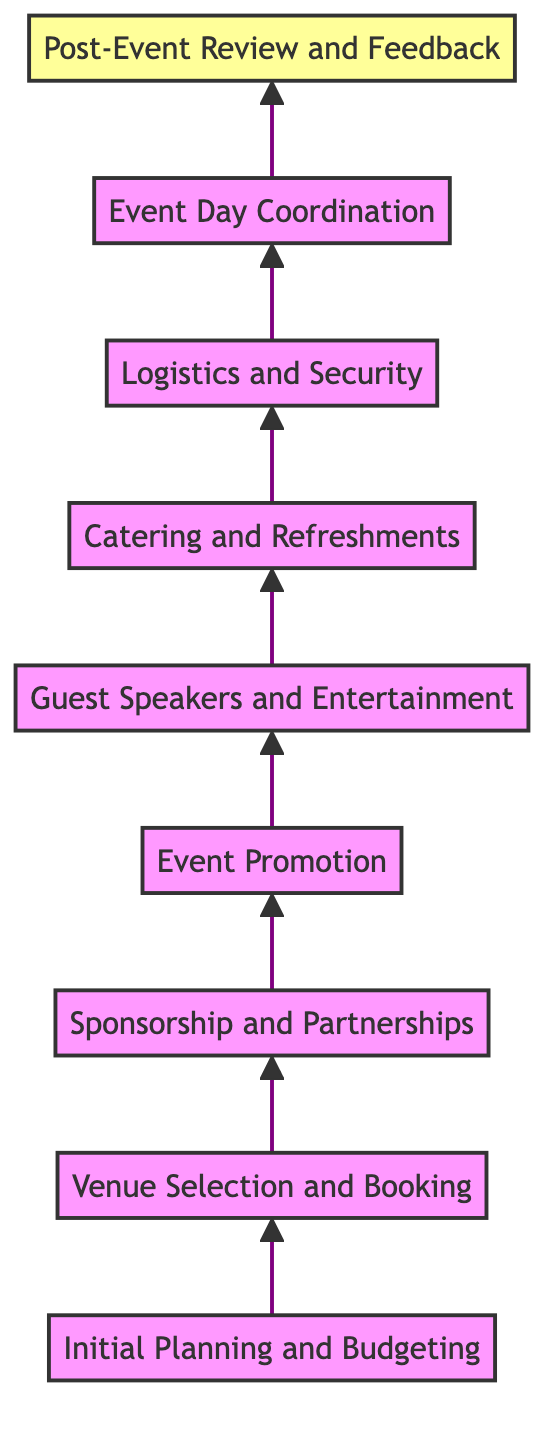What is the final step in the organization process? The flowchart indicates that the final step, after all other processes are completed, is "Post-Event Review and Feedback." This is the last node in the upward flow from the initial planning to the conclusion of the event organization.
Answer: Post-Event Review and Feedback How many total steps are in the diagram? The diagram consists of 9 distinct elements, starting from "Initial Planning and Budgeting" to "Post-Event Review and Feedback." Each step corresponds to an essential part of the event organization process.
Answer: 9 What is the relationship between "Event Promotion" and "Guest Speakers and Entertainment"? "Event Promotion" is a step that comes directly before "Guest Speakers and Entertainment" in the flowchart. This implies that promoting the event occurs prior to inviting speakers and entertainers, indicating a logical sequence in the planning process.
Answer: Event Promotion comes before Guest Speakers and Entertainment Which node involves coordinating safety measures? The node titled "Logistics and Security" is responsible for coordinating all safety measures related to the event. It comes after the food arrangements and before the actual day of the event, highlighting its importance in ensuring a secure environment.
Answer: Logistics and Security What step directly follows "Sponsorship and Partnerships"? The next step after "Sponsorship and Partnerships" is "Event Promotion." This indicates that securing sponsorship precedes the promotional activities which are crucial for raising awareness of the event.
Answer: Event Promotion Which step is characterized by inviting notable veterans? The step characterized by inviting notable veterans is "Guest Speakers and Entertainment." This is explicitly highlighted in the description of that particular node.
Answer: Guest Speakers and Entertainment What is the second step in the flowchart? The second step in the flowchart is "Venue Selection and Booking." This step follows the initial planning and is crucial for establishing the event's location.
Answer: Venue Selection and Booking How do you ensure event execution goes smoothly? "Event Day Coordination" specifically addresses ensuring the smooth execution of the event schedule and dealing with any issues that arise during the event. This reflects its importance on the day of the meetup.
Answer: Event Day Coordination What is the purpose of gathering feedback after the event? The purpose of gathering feedback during the "Post-Event Review and Feedback" step is to review the outcomes of the event and plan improvements for the next year's meetup. Feedback contributes to the overall growth and effectiveness of the future events.
Answer: Plan improvements for the next year 